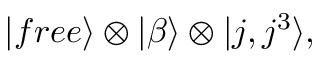Convert formula to latex. <formula><loc_0><loc_0><loc_500><loc_500>| f r e e \rangle \otimes | \beta \rangle \otimes | j , j ^ { 3 } \rangle ,</formula> 